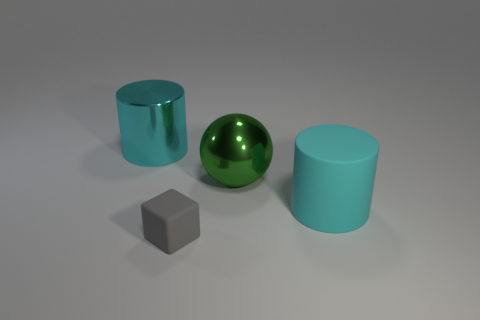How many things are to the left of the green metallic sphere and behind the tiny rubber block? To the left of the green metallic sphere and behind the tiny gray rubber block, there is only one object: a cyan-colored cylinder. 